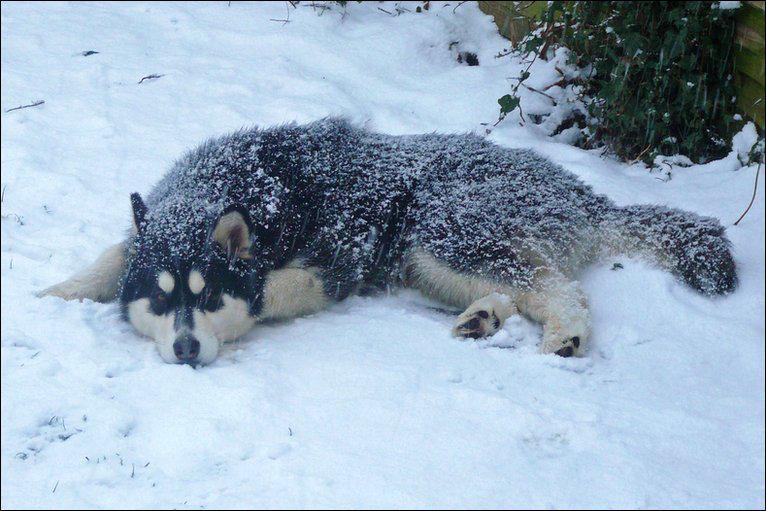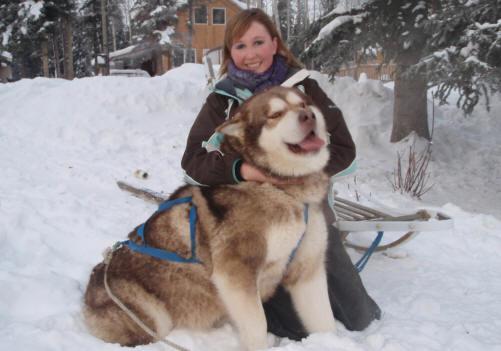The first image is the image on the left, the second image is the image on the right. Assess this claim about the two images: "At least one photo has two dogs, and at least three dogs have their mouths open.". Correct or not? Answer yes or no. No. The first image is the image on the left, the second image is the image on the right. Considering the images on both sides, is "In one of the images, two malamutes are sitting in the grass." valid? Answer yes or no. No. 